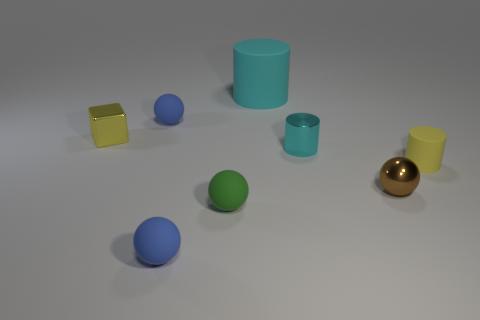Subtract 1 spheres. How many spheres are left? 3 Add 2 gray matte blocks. How many objects exist? 10 Subtract all cubes. How many objects are left? 7 Subtract all tiny spheres. Subtract all matte spheres. How many objects are left? 1 Add 7 small yellow matte cylinders. How many small yellow matte cylinders are left? 8 Add 1 brown shiny objects. How many brown shiny objects exist? 2 Subtract 0 yellow balls. How many objects are left? 8 